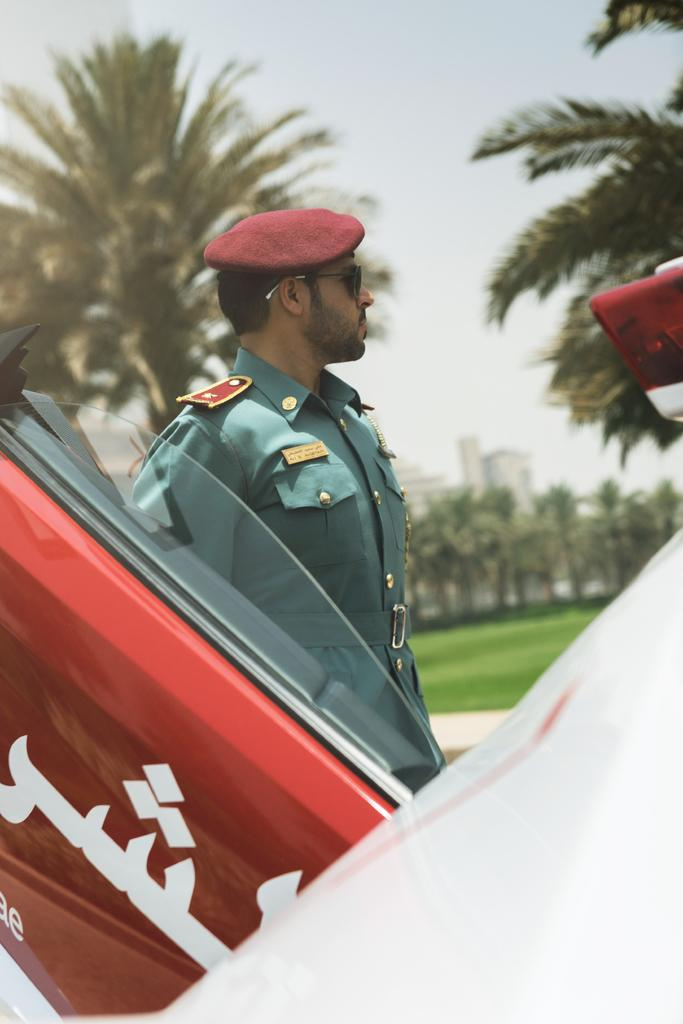Who is present in the image? There is a man in the image. What can be seen besides the man in the image? There is a vehicle, trees, grass, buildings, and the sky visible in the background of the image. What type of pot is being used to record the man's conversation in the image? There is no pot or recording device present in the image. 